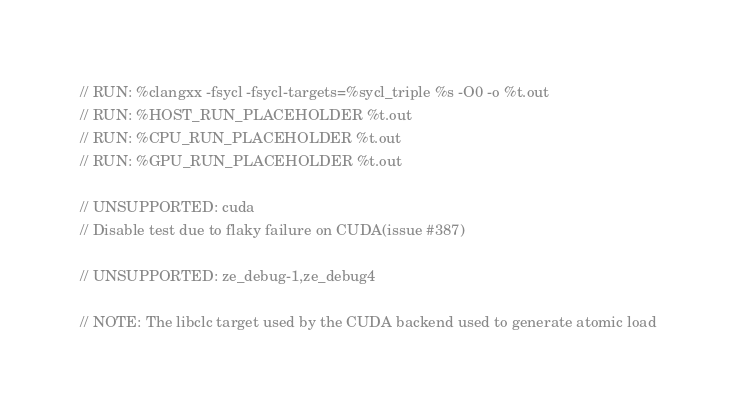Convert code to text. <code><loc_0><loc_0><loc_500><loc_500><_C++_>// RUN: %clangxx -fsycl -fsycl-targets=%sycl_triple %s -O0 -o %t.out
// RUN: %HOST_RUN_PLACEHOLDER %t.out
// RUN: %CPU_RUN_PLACEHOLDER %t.out
// RUN: %GPU_RUN_PLACEHOLDER %t.out

// UNSUPPORTED: cuda
// Disable test due to flaky failure on CUDA(issue #387)

// UNSUPPORTED: ze_debug-1,ze_debug4

// NOTE: The libclc target used by the CUDA backend used to generate atomic load</code> 